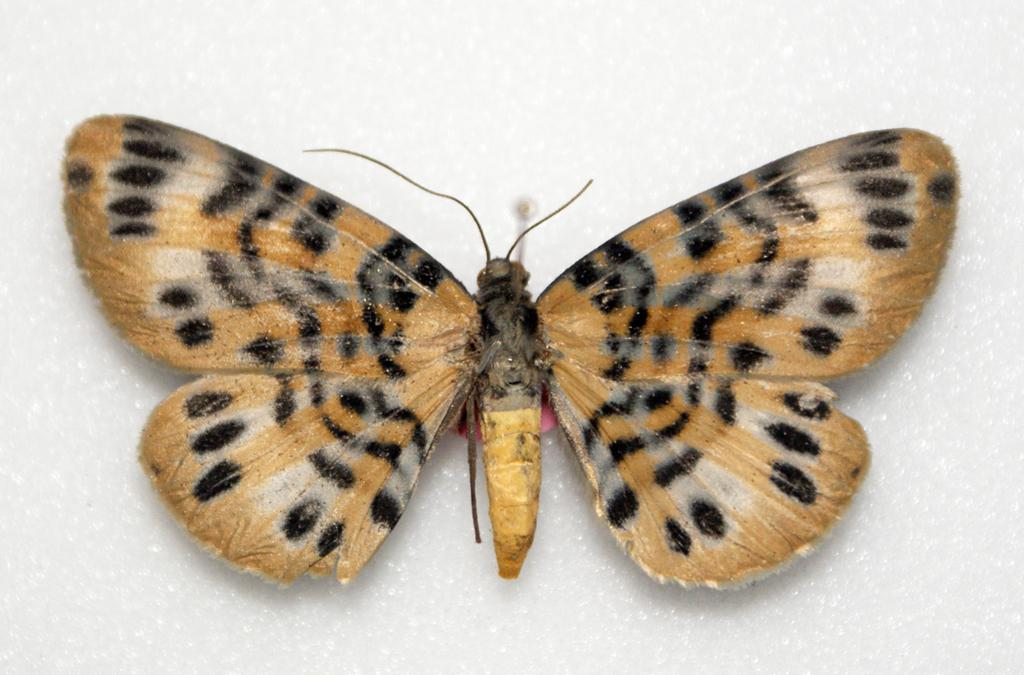What type of insect can be seen in the image? A: There is a butterfly in the image. What type of meal is being prepared in the image? There is no meal preparation visible in the image; it only features a butterfly. Is there a hose visible in the image? No, there is no hose present in the image; it only features a butterfly. 